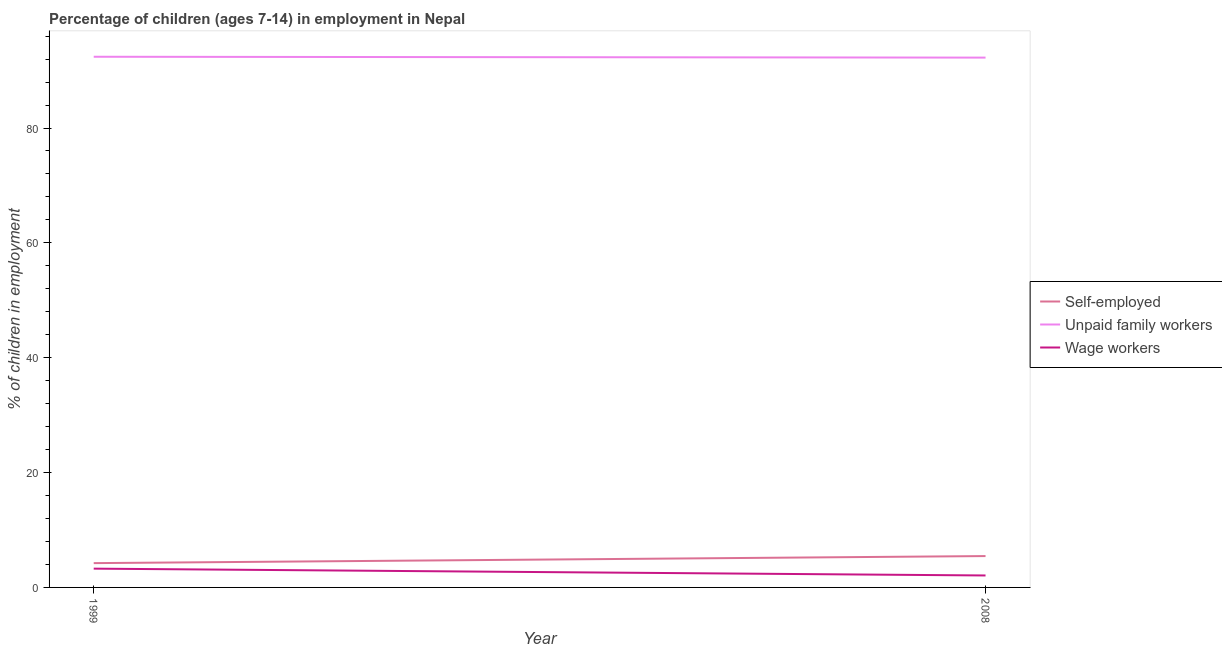Does the line corresponding to percentage of self employed children intersect with the line corresponding to percentage of children employed as unpaid family workers?
Give a very brief answer. No. Is the number of lines equal to the number of legend labels?
Offer a terse response. Yes. What is the percentage of children employed as wage workers in 2008?
Ensure brevity in your answer.  2.08. Across all years, what is the maximum percentage of children employed as wage workers?
Give a very brief answer. 3.27. Across all years, what is the minimum percentage of self employed children?
Offer a terse response. 4.23. In which year was the percentage of self employed children maximum?
Offer a terse response. 2008. What is the total percentage of children employed as unpaid family workers in the graph?
Provide a succinct answer. 184.67. What is the difference between the percentage of self employed children in 1999 and that in 2008?
Provide a succinct answer. -1.23. What is the difference between the percentage of children employed as unpaid family workers in 2008 and the percentage of children employed as wage workers in 1999?
Give a very brief answer. 88.99. What is the average percentage of self employed children per year?
Provide a succinct answer. 4.85. In the year 2008, what is the difference between the percentage of children employed as wage workers and percentage of self employed children?
Your answer should be very brief. -3.38. What is the ratio of the percentage of children employed as unpaid family workers in 1999 to that in 2008?
Give a very brief answer. 1. Is the percentage of children employed as unpaid family workers strictly greater than the percentage of self employed children over the years?
Ensure brevity in your answer.  Yes. How many lines are there?
Ensure brevity in your answer.  3. What is the difference between two consecutive major ticks on the Y-axis?
Your answer should be compact. 20. Does the graph contain any zero values?
Offer a very short reply. No. Does the graph contain grids?
Provide a short and direct response. No. What is the title of the graph?
Offer a very short reply. Percentage of children (ages 7-14) in employment in Nepal. What is the label or title of the X-axis?
Ensure brevity in your answer.  Year. What is the label or title of the Y-axis?
Offer a very short reply. % of children in employment. What is the % of children in employment of Self-employed in 1999?
Make the answer very short. 4.23. What is the % of children in employment of Unpaid family workers in 1999?
Offer a very short reply. 92.41. What is the % of children in employment in Wage workers in 1999?
Offer a very short reply. 3.27. What is the % of children in employment of Self-employed in 2008?
Your answer should be compact. 5.46. What is the % of children in employment in Unpaid family workers in 2008?
Make the answer very short. 92.26. What is the % of children in employment in Wage workers in 2008?
Offer a terse response. 2.08. Across all years, what is the maximum % of children in employment in Self-employed?
Make the answer very short. 5.46. Across all years, what is the maximum % of children in employment in Unpaid family workers?
Make the answer very short. 92.41. Across all years, what is the maximum % of children in employment in Wage workers?
Your answer should be compact. 3.27. Across all years, what is the minimum % of children in employment in Self-employed?
Your answer should be compact. 4.23. Across all years, what is the minimum % of children in employment in Unpaid family workers?
Provide a short and direct response. 92.26. Across all years, what is the minimum % of children in employment of Wage workers?
Keep it short and to the point. 2.08. What is the total % of children in employment in Self-employed in the graph?
Provide a short and direct response. 9.69. What is the total % of children in employment in Unpaid family workers in the graph?
Provide a short and direct response. 184.67. What is the total % of children in employment in Wage workers in the graph?
Make the answer very short. 5.35. What is the difference between the % of children in employment in Self-employed in 1999 and that in 2008?
Keep it short and to the point. -1.23. What is the difference between the % of children in employment in Unpaid family workers in 1999 and that in 2008?
Ensure brevity in your answer.  0.15. What is the difference between the % of children in employment of Wage workers in 1999 and that in 2008?
Give a very brief answer. 1.19. What is the difference between the % of children in employment in Self-employed in 1999 and the % of children in employment in Unpaid family workers in 2008?
Keep it short and to the point. -88.03. What is the difference between the % of children in employment in Self-employed in 1999 and the % of children in employment in Wage workers in 2008?
Make the answer very short. 2.15. What is the difference between the % of children in employment in Unpaid family workers in 1999 and the % of children in employment in Wage workers in 2008?
Offer a terse response. 90.33. What is the average % of children in employment of Self-employed per year?
Give a very brief answer. 4.84. What is the average % of children in employment in Unpaid family workers per year?
Your answer should be very brief. 92.33. What is the average % of children in employment in Wage workers per year?
Provide a short and direct response. 2.67. In the year 1999, what is the difference between the % of children in employment of Self-employed and % of children in employment of Unpaid family workers?
Provide a succinct answer. -88.18. In the year 1999, what is the difference between the % of children in employment of Self-employed and % of children in employment of Wage workers?
Offer a terse response. 0.96. In the year 1999, what is the difference between the % of children in employment in Unpaid family workers and % of children in employment in Wage workers?
Provide a succinct answer. 89.14. In the year 2008, what is the difference between the % of children in employment in Self-employed and % of children in employment in Unpaid family workers?
Keep it short and to the point. -86.8. In the year 2008, what is the difference between the % of children in employment of Self-employed and % of children in employment of Wage workers?
Your response must be concise. 3.38. In the year 2008, what is the difference between the % of children in employment in Unpaid family workers and % of children in employment in Wage workers?
Offer a terse response. 90.18. What is the ratio of the % of children in employment in Self-employed in 1999 to that in 2008?
Your answer should be very brief. 0.77. What is the ratio of the % of children in employment in Unpaid family workers in 1999 to that in 2008?
Ensure brevity in your answer.  1. What is the ratio of the % of children in employment in Wage workers in 1999 to that in 2008?
Offer a terse response. 1.57. What is the difference between the highest and the second highest % of children in employment of Self-employed?
Ensure brevity in your answer.  1.23. What is the difference between the highest and the second highest % of children in employment of Unpaid family workers?
Your answer should be very brief. 0.15. What is the difference between the highest and the second highest % of children in employment of Wage workers?
Your answer should be compact. 1.19. What is the difference between the highest and the lowest % of children in employment of Self-employed?
Provide a succinct answer. 1.23. What is the difference between the highest and the lowest % of children in employment in Wage workers?
Your answer should be compact. 1.19. 